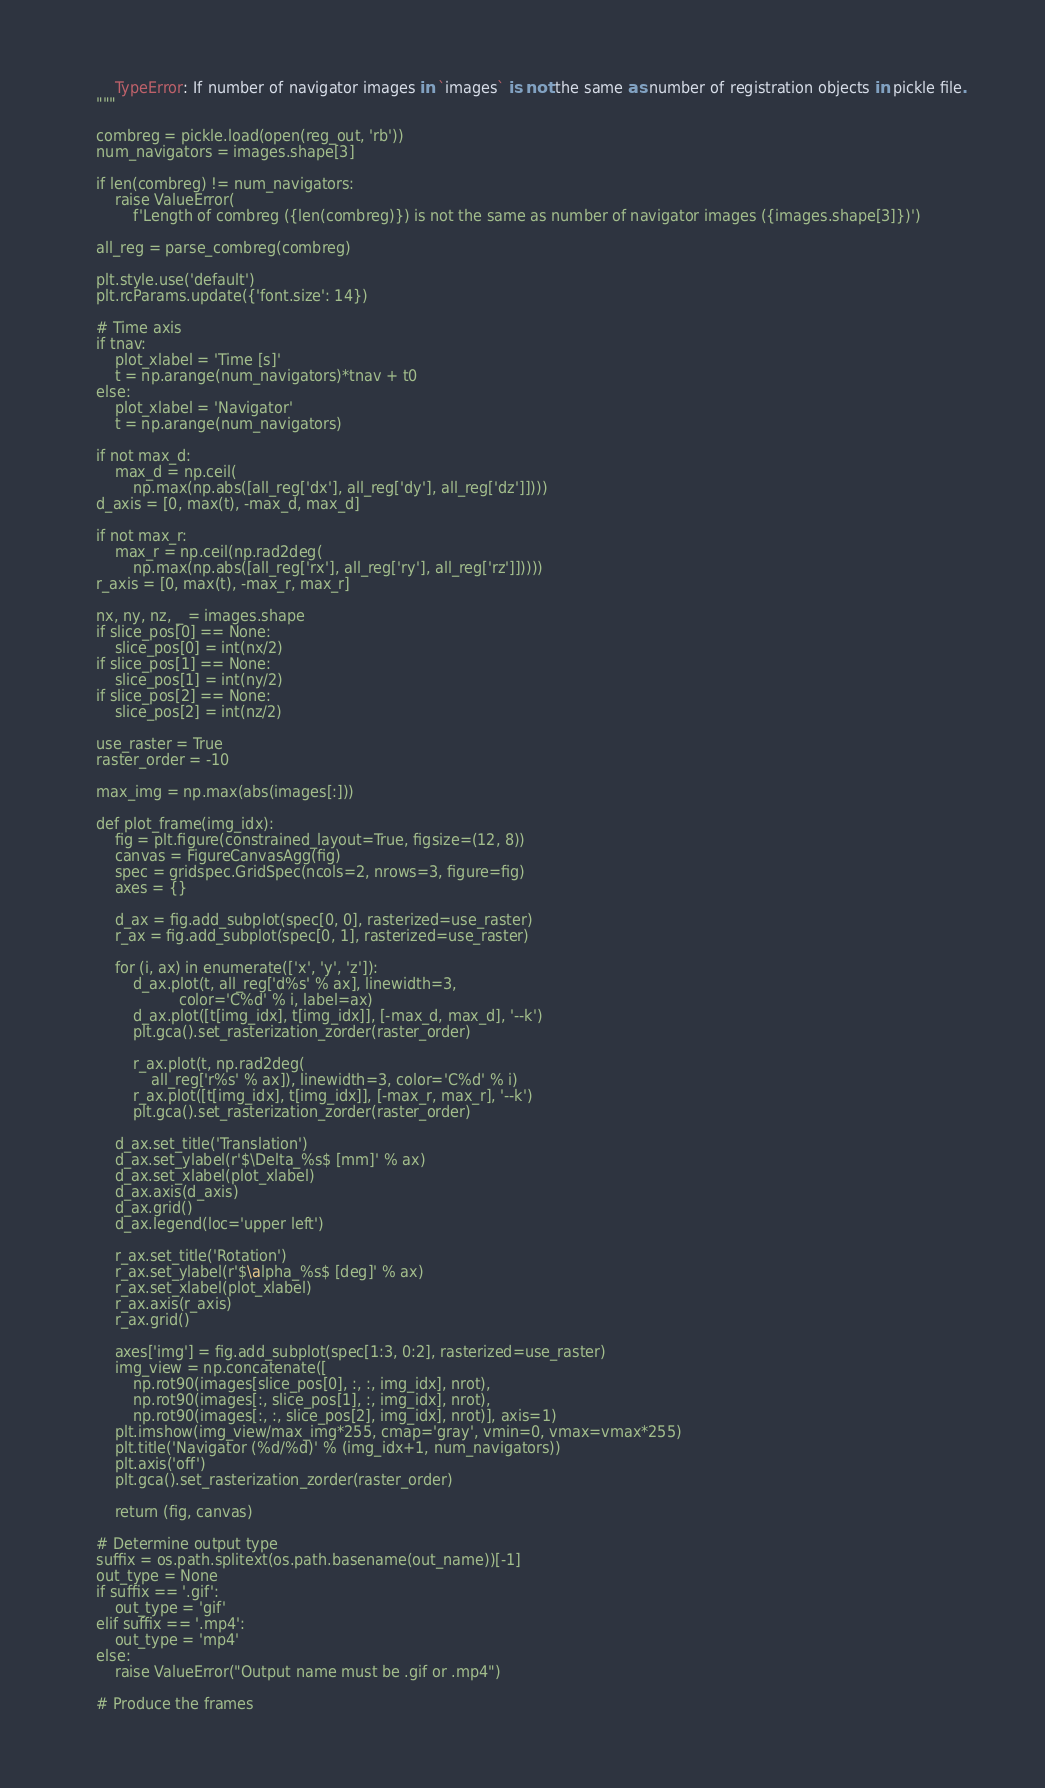<code> <loc_0><loc_0><loc_500><loc_500><_Python_>        TypeError: If number of navigator images in `images` is not the same as number of registration objects in pickle file.
    """

    combreg = pickle.load(open(reg_out, 'rb'))
    num_navigators = images.shape[3]

    if len(combreg) != num_navigators:
        raise ValueError(
            f'Length of combreg ({len(combreg)}) is not the same as number of navigator images ({images.shape[3]})')

    all_reg = parse_combreg(combreg)

    plt.style.use('default')
    plt.rcParams.update({'font.size': 14})

    # Time axis
    if tnav:
        plot_xlabel = 'Time [s]'
        t = np.arange(num_navigators)*tnav + t0
    else:
        plot_xlabel = 'Navigator'
        t = np.arange(num_navigators)

    if not max_d:
        max_d = np.ceil(
            np.max(np.abs([all_reg['dx'], all_reg['dy'], all_reg['dz']])))
    d_axis = [0, max(t), -max_d, max_d]

    if not max_r:
        max_r = np.ceil(np.rad2deg(
            np.max(np.abs([all_reg['rx'], all_reg['ry'], all_reg['rz']]))))
    r_axis = [0, max(t), -max_r, max_r]

    nx, ny, nz, _ = images.shape
    if slice_pos[0] == None:
        slice_pos[0] = int(nx/2)
    if slice_pos[1] == None:
        slice_pos[1] = int(ny/2)
    if slice_pos[2] == None:
        slice_pos[2] = int(nz/2)

    use_raster = True
    raster_order = -10

    max_img = np.max(abs(images[:]))

    def plot_frame(img_idx):
        fig = plt.figure(constrained_layout=True, figsize=(12, 8))
        canvas = FigureCanvasAgg(fig)
        spec = gridspec.GridSpec(ncols=2, nrows=3, figure=fig)
        axes = {}

        d_ax = fig.add_subplot(spec[0, 0], rasterized=use_raster)
        r_ax = fig.add_subplot(spec[0, 1], rasterized=use_raster)

        for (i, ax) in enumerate(['x', 'y', 'z']):
            d_ax.plot(t, all_reg['d%s' % ax], linewidth=3,
                      color='C%d' % i, label=ax)
            d_ax.plot([t[img_idx], t[img_idx]], [-max_d, max_d], '--k')
            plt.gca().set_rasterization_zorder(raster_order)

            r_ax.plot(t, np.rad2deg(
                all_reg['r%s' % ax]), linewidth=3, color='C%d' % i)
            r_ax.plot([t[img_idx], t[img_idx]], [-max_r, max_r], '--k')
            plt.gca().set_rasterization_zorder(raster_order)

        d_ax.set_title('Translation')
        d_ax.set_ylabel(r'$\Delta_%s$ [mm]' % ax)
        d_ax.set_xlabel(plot_xlabel)
        d_ax.axis(d_axis)
        d_ax.grid()
        d_ax.legend(loc='upper left')

        r_ax.set_title('Rotation')
        r_ax.set_ylabel(r'$\alpha_%s$ [deg]' % ax)
        r_ax.set_xlabel(plot_xlabel)
        r_ax.axis(r_axis)
        r_ax.grid()

        axes['img'] = fig.add_subplot(spec[1:3, 0:2], rasterized=use_raster)
        img_view = np.concatenate([
            np.rot90(images[slice_pos[0], :, :, img_idx], nrot),
            np.rot90(images[:, slice_pos[1], :, img_idx], nrot),
            np.rot90(images[:, :, slice_pos[2], img_idx], nrot)], axis=1)
        plt.imshow(img_view/max_img*255, cmap='gray', vmin=0, vmax=vmax*255)
        plt.title('Navigator (%d/%d)' % (img_idx+1, num_navigators))
        plt.axis('off')
        plt.gca().set_rasterization_zorder(raster_order)

        return (fig, canvas)

    # Determine output type
    suffix = os.path.splitext(os.path.basename(out_name))[-1]
    out_type = None
    if suffix == '.gif':
        out_type = 'gif'
    elif suffix == '.mp4':
        out_type = 'mp4'
    else:
        raise ValueError("Output name must be .gif or .mp4")

    # Produce the frames</code> 